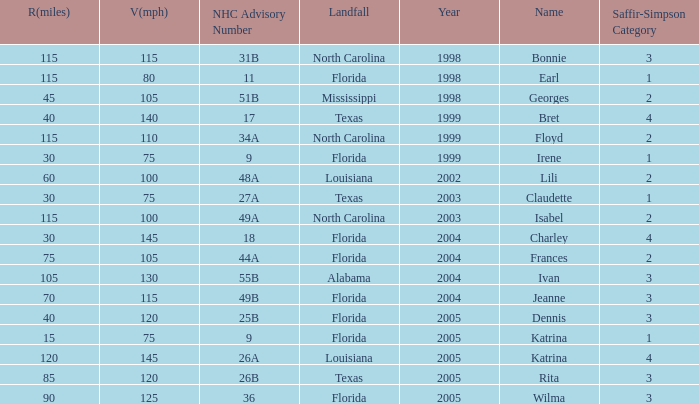Which landfall was in category 1 for Saffir-Simpson in 1999? Florida. 